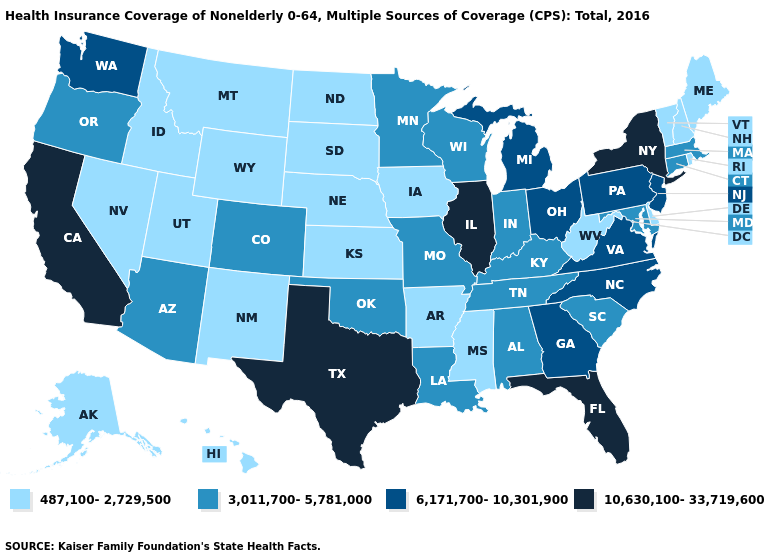Among the states that border Wyoming , does Colorado have the lowest value?
Concise answer only. No. What is the lowest value in the USA?
Keep it brief. 487,100-2,729,500. Name the states that have a value in the range 487,100-2,729,500?
Concise answer only. Alaska, Arkansas, Delaware, Hawaii, Idaho, Iowa, Kansas, Maine, Mississippi, Montana, Nebraska, Nevada, New Hampshire, New Mexico, North Dakota, Rhode Island, South Dakota, Utah, Vermont, West Virginia, Wyoming. How many symbols are there in the legend?
Quick response, please. 4. What is the highest value in the USA?
Give a very brief answer. 10,630,100-33,719,600. What is the highest value in the West ?
Write a very short answer. 10,630,100-33,719,600. Name the states that have a value in the range 10,630,100-33,719,600?
Quick response, please. California, Florida, Illinois, New York, Texas. What is the highest value in the South ?
Write a very short answer. 10,630,100-33,719,600. Name the states that have a value in the range 487,100-2,729,500?
Concise answer only. Alaska, Arkansas, Delaware, Hawaii, Idaho, Iowa, Kansas, Maine, Mississippi, Montana, Nebraska, Nevada, New Hampshire, New Mexico, North Dakota, Rhode Island, South Dakota, Utah, Vermont, West Virginia, Wyoming. Name the states that have a value in the range 3,011,700-5,781,000?
Be succinct. Alabama, Arizona, Colorado, Connecticut, Indiana, Kentucky, Louisiana, Maryland, Massachusetts, Minnesota, Missouri, Oklahoma, Oregon, South Carolina, Tennessee, Wisconsin. What is the highest value in states that border Alabama?
Quick response, please. 10,630,100-33,719,600. Among the states that border Oklahoma , which have the highest value?
Short answer required. Texas. What is the value of Maryland?
Keep it brief. 3,011,700-5,781,000. Does Nebraska have the highest value in the MidWest?
Keep it brief. No. Among the states that border Mississippi , does Tennessee have the highest value?
Short answer required. Yes. 